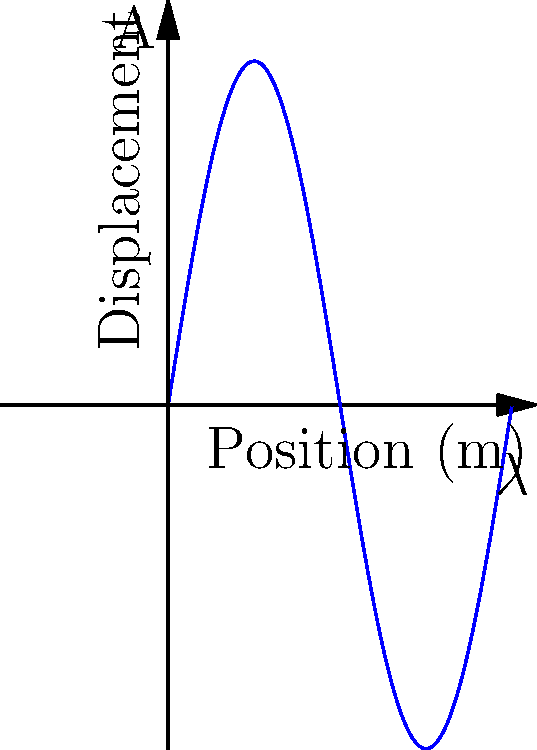As a guitarist, you're curious about the physics of your instrument. Consider a guitar string with a length of 0.65 m that produces a fundamental frequency of 440 Hz (A4 note). What is the wavelength of the standing wave on this string? To solve this problem, we'll use the relationship between wavelength, frequency, and wave speed. Let's approach this step-by-step:

1) First, recall the wave equation: $v = f\lambda$, where $v$ is the wave speed, $f$ is the frequency, and $\lambda$ is the wavelength.

2) For a string fixed at both ends (like a guitar string), the fundamental frequency corresponds to a standing wave with a wavelength twice the length of the string. So, $L = \frac{\lambda}{2}$, where $L$ is the length of the string.

3) We're given:
   - Length of string, $L = 0.65$ m
   - Fundamental frequency, $f = 440$ Hz

4) Using the relationship from step 2:
   $\lambda = 2L = 2 * 0.65 \text{ m} = 1.3 \text{ m}$

5) We can verify this using the wave equation if we know the wave speed. The wave speed in a string depends on its tension and linear density, but we don't need to calculate it here.

Therefore, the wavelength of the standing wave on the guitar string is 1.3 m.
Answer: 1.3 m 